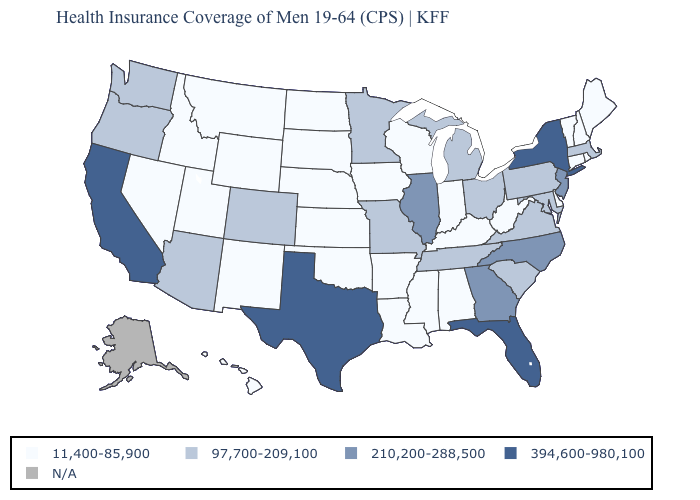What is the value of Georgia?
Short answer required. 210,200-288,500. Is the legend a continuous bar?
Keep it brief. No. What is the value of Nebraska?
Answer briefly. 11,400-85,900. Name the states that have a value in the range 394,600-980,100?
Quick response, please. California, Florida, New York, Texas. What is the value of Virginia?
Write a very short answer. 97,700-209,100. What is the value of Arizona?
Give a very brief answer. 97,700-209,100. Does Oklahoma have the lowest value in the South?
Quick response, please. Yes. What is the lowest value in the USA?
Write a very short answer. 11,400-85,900. Which states have the highest value in the USA?
Quick response, please. California, Florida, New York, Texas. Among the states that border Maryland , does Pennsylvania have the highest value?
Write a very short answer. Yes. Does Indiana have the highest value in the MidWest?
Keep it brief. No. Among the states that border Nevada , which have the lowest value?
Short answer required. Idaho, Utah. Does Kentucky have the lowest value in the USA?
Quick response, please. Yes. Among the states that border West Virginia , which have the lowest value?
Quick response, please. Kentucky. 